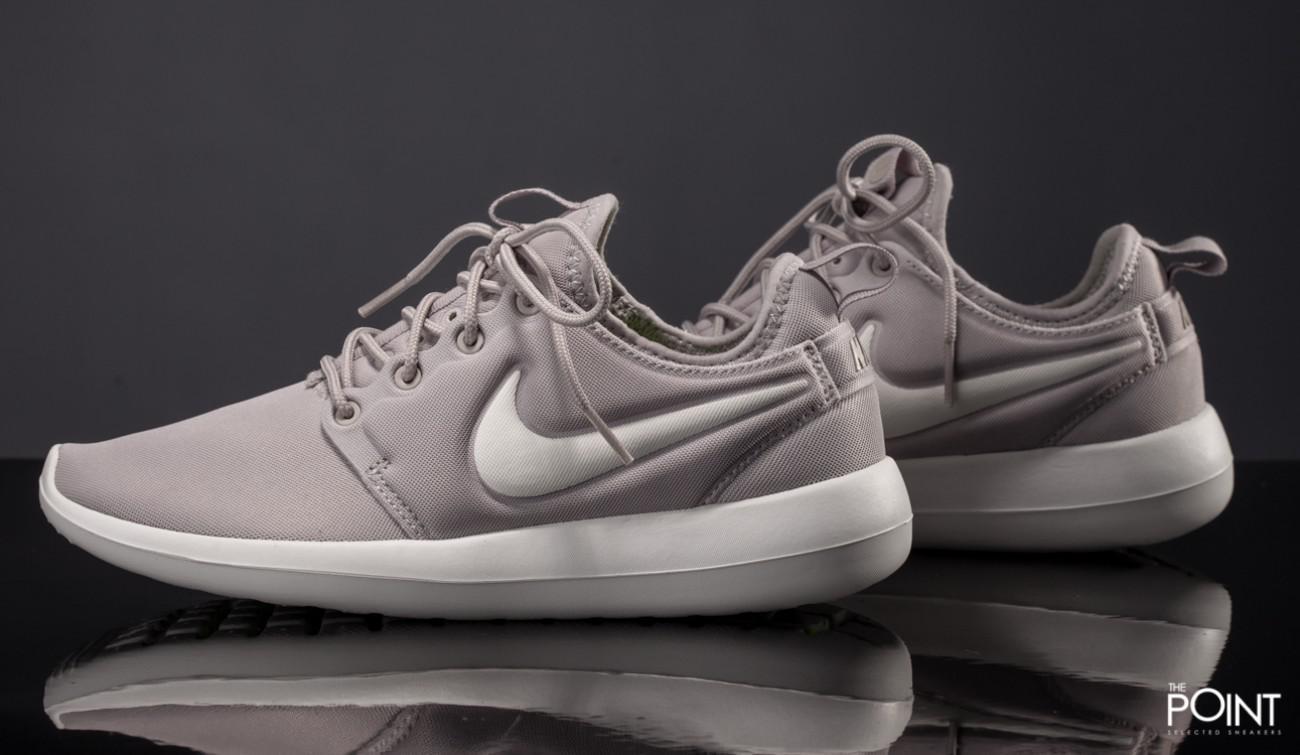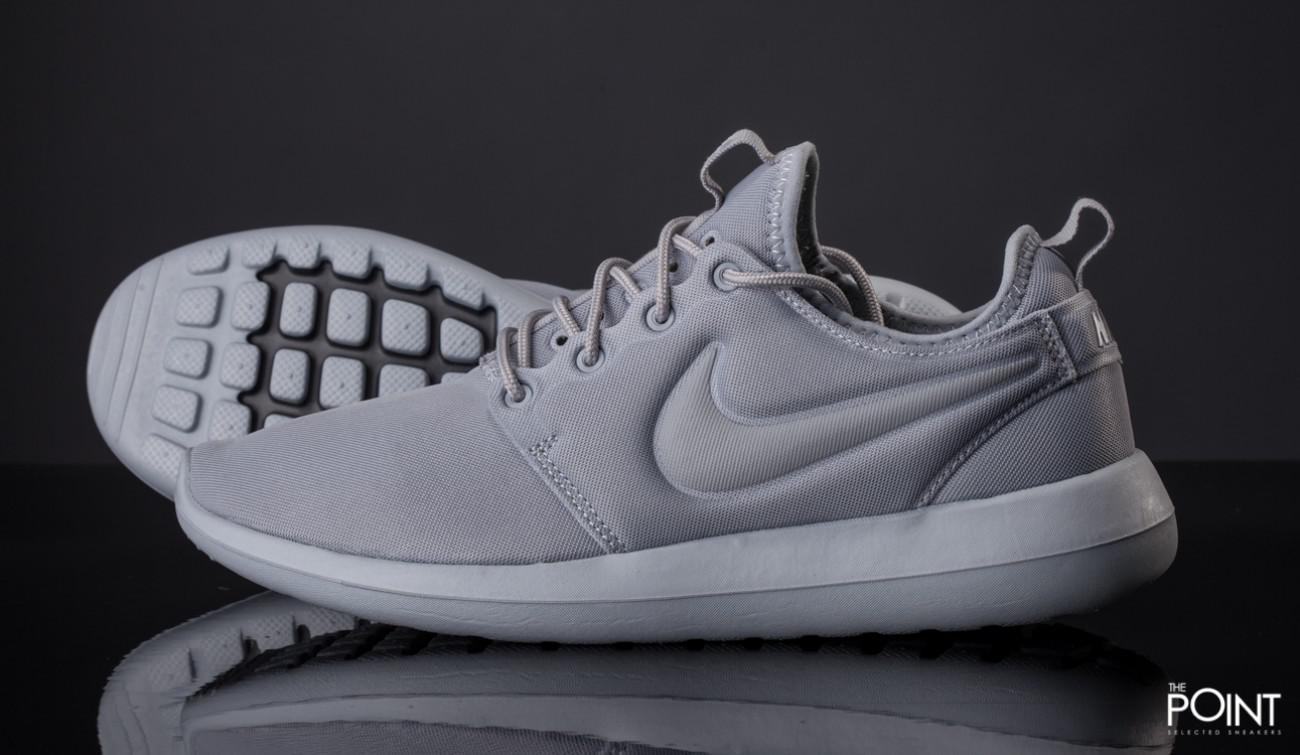The first image is the image on the left, the second image is the image on the right. Considering the images on both sides, is "Each image contains one unworn, matched pair of sneakers posed soles-downward, and the sneakers in the left and right images face inward toward each other." valid? Answer yes or no. No. The first image is the image on the left, the second image is the image on the right. For the images displayed, is the sentence "Both images show a pair of grey sneakers that aren't currently worn by anyone." factually correct? Answer yes or no. Yes. 